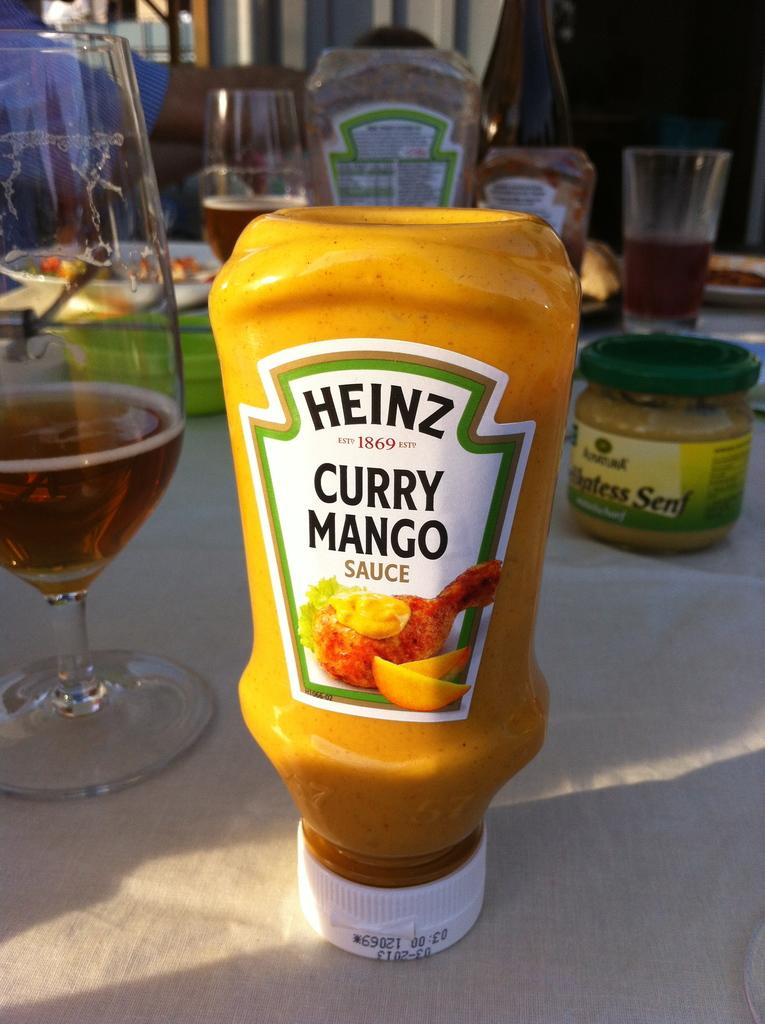What is the color and type of bottle in the image? There is a yellow color bottle with a label in the image. What can be seen in the background of the image? There are glasses with a drink and jars in the background of the image. What is placed on the table in the background of the image? There is a plate with food placed on the table in the background of the image. How does the knee contribute to the preparation of the food on the plate in the image? There is no mention of a knee or any food preparation in the image; it only shows a yellow color bottle, glasses with a drink, jars, and a plate with food. 